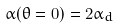Convert formula to latex. <formula><loc_0><loc_0><loc_500><loc_500>\alpha ( \theta = 0 ) = 2 \alpha _ { d }</formula> 